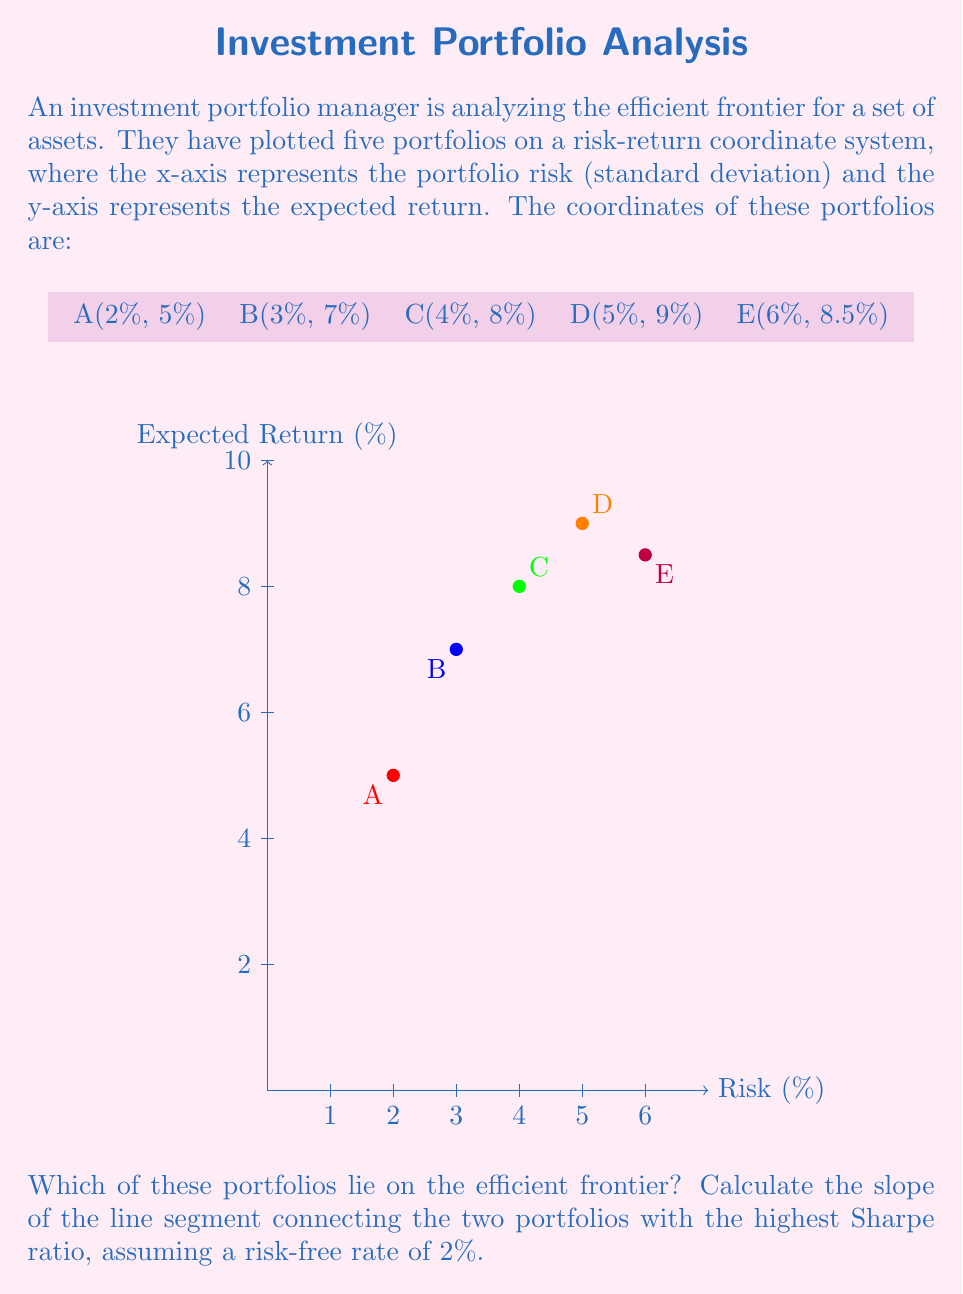Can you answer this question? To solve this problem, we need to follow these steps:

1. Identify the portfolios on the efficient frontier:
   The efficient frontier consists of portfolios that offer the highest expected return for a given level of risk. Looking at the graph, we can see that portfolios A, B, C, and D form a convex curve, while E falls below this curve. Therefore, A, B, C, and D are on the efficient frontier, while E is not.

2. Calculate the Sharpe ratio for each portfolio on the efficient frontier:
   The Sharpe ratio is given by the formula:
   $$ S = \frac{R_p - R_f}{\sigma_p} $$
   where $R_p$ is the portfolio return, $R_f$ is the risk-free rate, and $\sigma_p$ is the portfolio standard deviation (risk).

   For each portfolio:
   A: $S_A = \frac{5\% - 2\%}{2\%} = 1.5$
   B: $S_B = \frac{7\% - 2\%}{3\%} = 1.67$
   C: $S_C = \frac{8\% - 2\%}{4\%} = 1.5$
   D: $S_D = \frac{9\% - 2\%}{5\%} = 1.4$

3. Identify the two portfolios with the highest Sharpe ratios:
   Portfolio B has the highest Sharpe ratio (1.67), followed by portfolios A and C (both 1.5).
   We'll use B and A for our calculation as A has lower risk.

4. Calculate the slope of the line segment connecting A and B:
   The slope is given by the formula:
   $$ m = \frac{y_2 - y_1}{x_2 - x_1} = \frac{R_B - R_A}{\sigma_B - \sigma_A} $$

   Plugging in the values:
   $$ m = \frac{7\% - 5\%}{3\% - 2\%} = \frac{2\%}{1\%} = 2 $$

Therefore, the slope of the line segment connecting the two portfolios with the highest Sharpe ratio is 2.
Answer: Efficient frontier portfolios: A, B, C, D. Slope between highest Sharpe ratio portfolios: 2. 